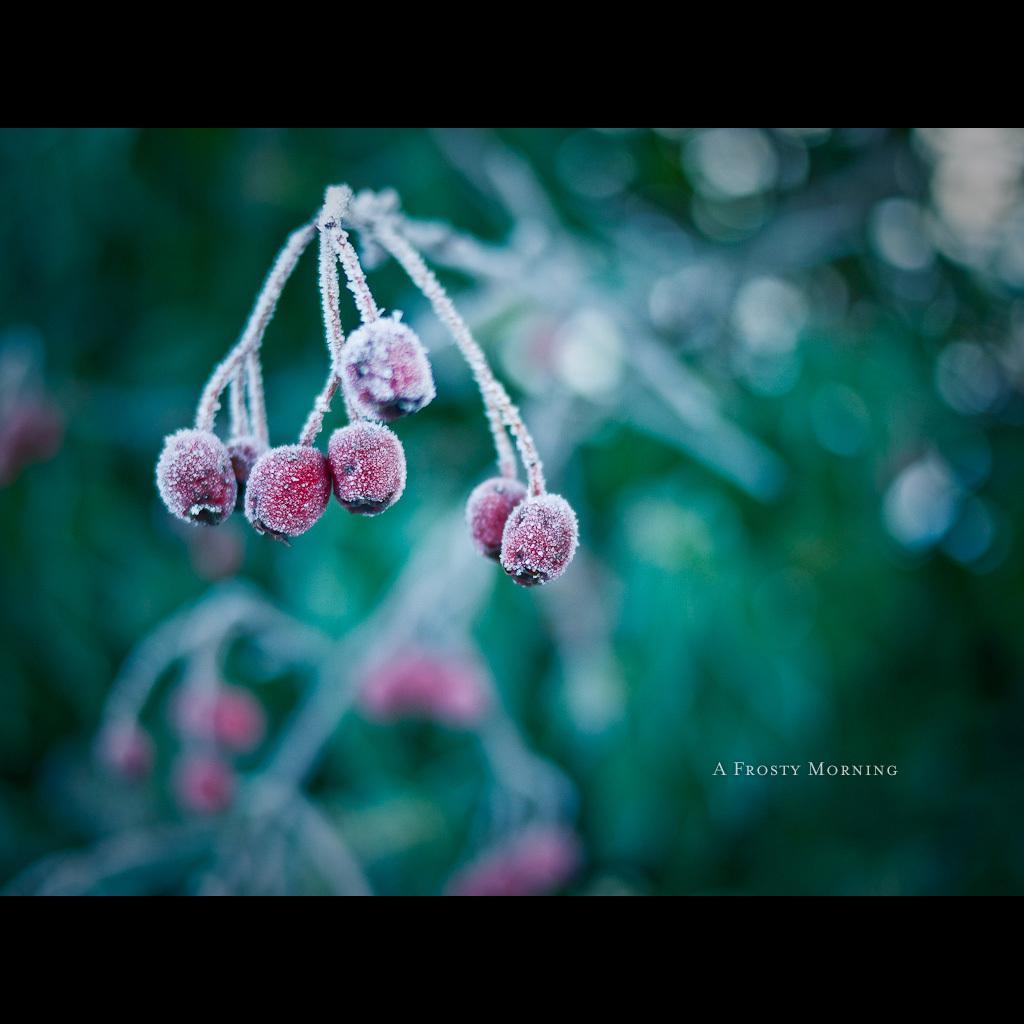Could you give a brief overview of what you see in this image? In this image we can see fruits and green stem, in the background it is blurred. 